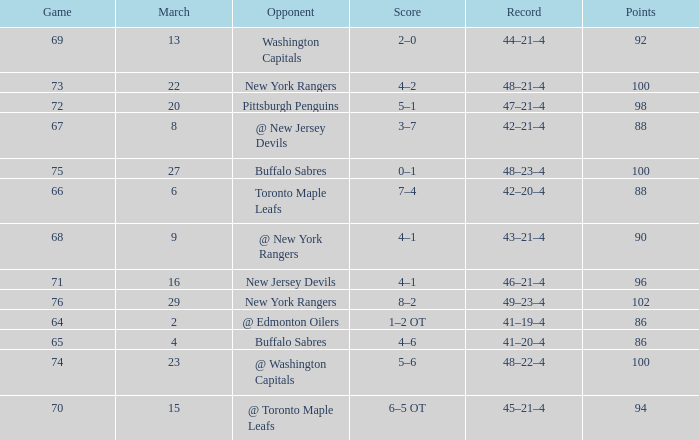Which March is the lowest one that has a Score of 5–6, and Points smaller than 100? None. 